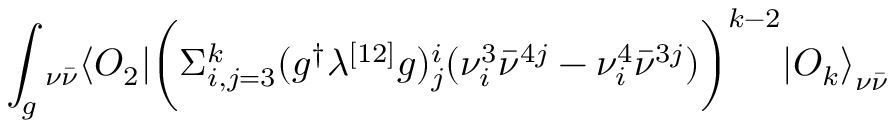<formula> <loc_0><loc_0><loc_500><loc_500>\int _ { g _ { \nu \bar { \nu } } \langle O _ { 2 } | \left ( \Sigma _ { i , j = 3 } ^ { k } ( g ^ { \dagger } \lambda ^ { [ 1 2 ] } g ) _ { j } ^ { i } ( \nu _ { i } ^ { 3 } { \bar { \nu } } ^ { 4 j } - \nu _ { i } ^ { 4 } { \bar { \nu } } ^ { 3 j } ) \right ) ^ { k - 2 } { | O _ { k } \rangle } _ { \nu \bar { \nu } }</formula> 